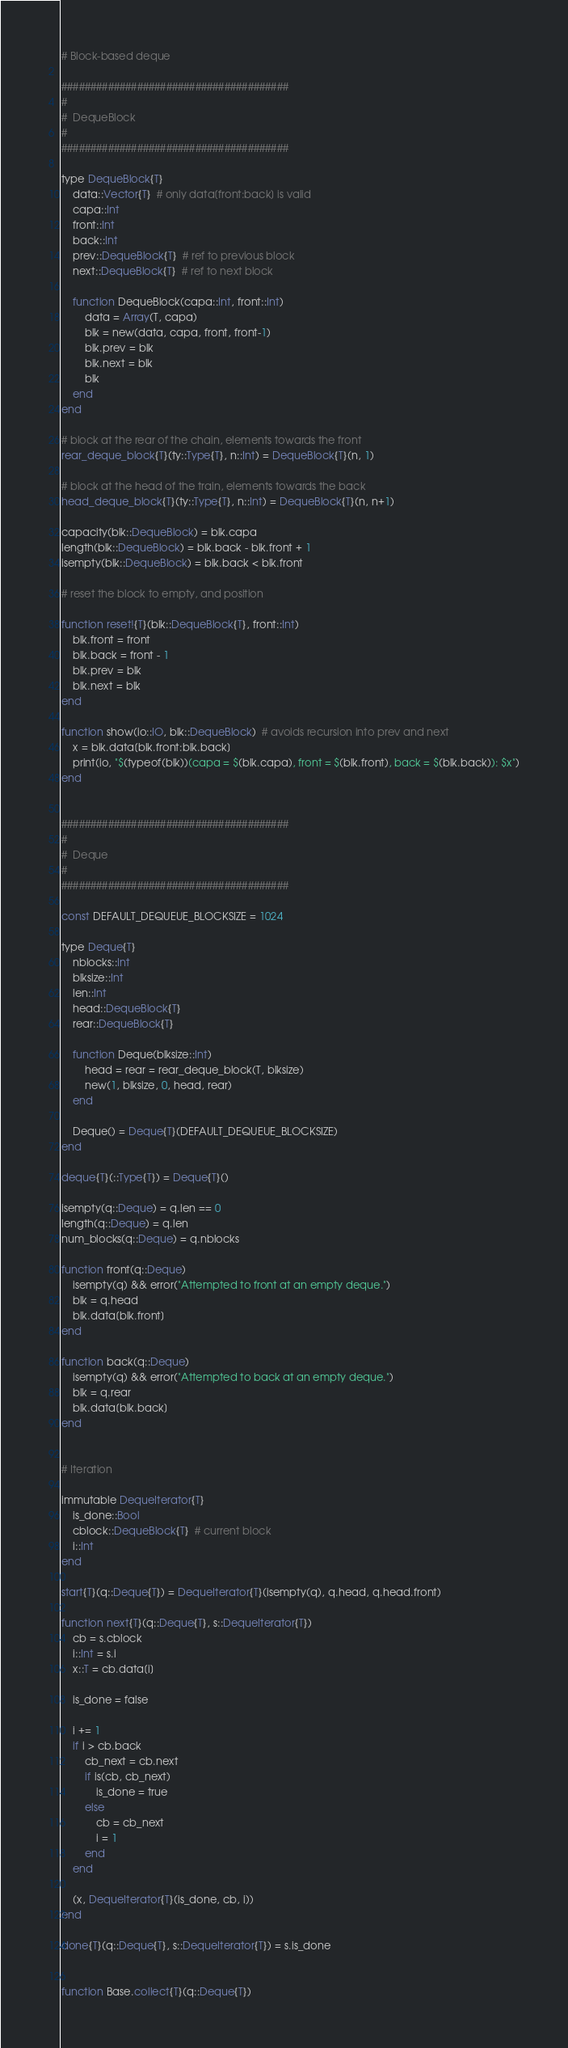Convert code to text. <code><loc_0><loc_0><loc_500><loc_500><_Julia_># Block-based deque

#######################################
#
#  DequeBlock
#
#######################################

type DequeBlock{T}
    data::Vector{T}  # only data[front:back] is valid
    capa::Int
    front::Int
    back::Int
    prev::DequeBlock{T}  # ref to previous block
    next::DequeBlock{T}  # ref to next block

    function DequeBlock(capa::Int, front::Int)
        data = Array(T, capa)
        blk = new(data, capa, front, front-1)
        blk.prev = blk
        blk.next = blk
        blk
    end
end

# block at the rear of the chain, elements towards the front
rear_deque_block{T}(ty::Type{T}, n::Int) = DequeBlock{T}(n, 1)

# block at the head of the train, elements towards the back
head_deque_block{T}(ty::Type{T}, n::Int) = DequeBlock{T}(n, n+1)

capacity(blk::DequeBlock) = blk.capa
length(blk::DequeBlock) = blk.back - blk.front + 1
isempty(blk::DequeBlock) = blk.back < blk.front

# reset the block to empty, and position

function reset!{T}(blk::DequeBlock{T}, front::Int)
    blk.front = front
    blk.back = front - 1
    blk.prev = blk
    blk.next = blk
end

function show(io::IO, blk::DequeBlock)  # avoids recursion into prev and next
    x = blk.data[blk.front:blk.back]
    print(io, "$(typeof(blk))(capa = $(blk.capa), front = $(blk.front), back = $(blk.back)): $x")
end


#######################################
#
#  Deque
#
#######################################

const DEFAULT_DEQUEUE_BLOCKSIZE = 1024

type Deque{T}
    nblocks::Int
    blksize::Int
    len::Int
    head::DequeBlock{T}
    rear::DequeBlock{T}

    function Deque(blksize::Int)
        head = rear = rear_deque_block(T, blksize)
        new(1, blksize, 0, head, rear)
    end

    Deque() = Deque{T}(DEFAULT_DEQUEUE_BLOCKSIZE)
end

deque{T}(::Type{T}) = Deque{T}()

isempty(q::Deque) = q.len == 0
length(q::Deque) = q.len
num_blocks(q::Deque) = q.nblocks

function front(q::Deque)
    isempty(q) && error("Attempted to front at an empty deque.")
    blk = q.head
    blk.data[blk.front]
end

function back(q::Deque)
    isempty(q) && error("Attempted to back at an empty deque.")
    blk = q.rear
    blk.data[blk.back]
end


# Iteration

immutable DequeIterator{T}
    is_done::Bool
    cblock::DequeBlock{T}  # current block
    i::Int
end

start{T}(q::Deque{T}) = DequeIterator{T}(isempty(q), q.head, q.head.front)

function next{T}(q::Deque{T}, s::DequeIterator{T})
    cb = s.cblock
    i::Int = s.i
    x::T = cb.data[i]

    is_done = false

    i += 1
    if i > cb.back
        cb_next = cb.next
        if is(cb, cb_next)
            is_done = true
        else
            cb = cb_next
            i = 1
        end
    end

    (x, DequeIterator{T}(is_done, cb, i))
end

done{T}(q::Deque{T}, s::DequeIterator{T}) = s.is_done


function Base.collect{T}(q::Deque{T})</code> 